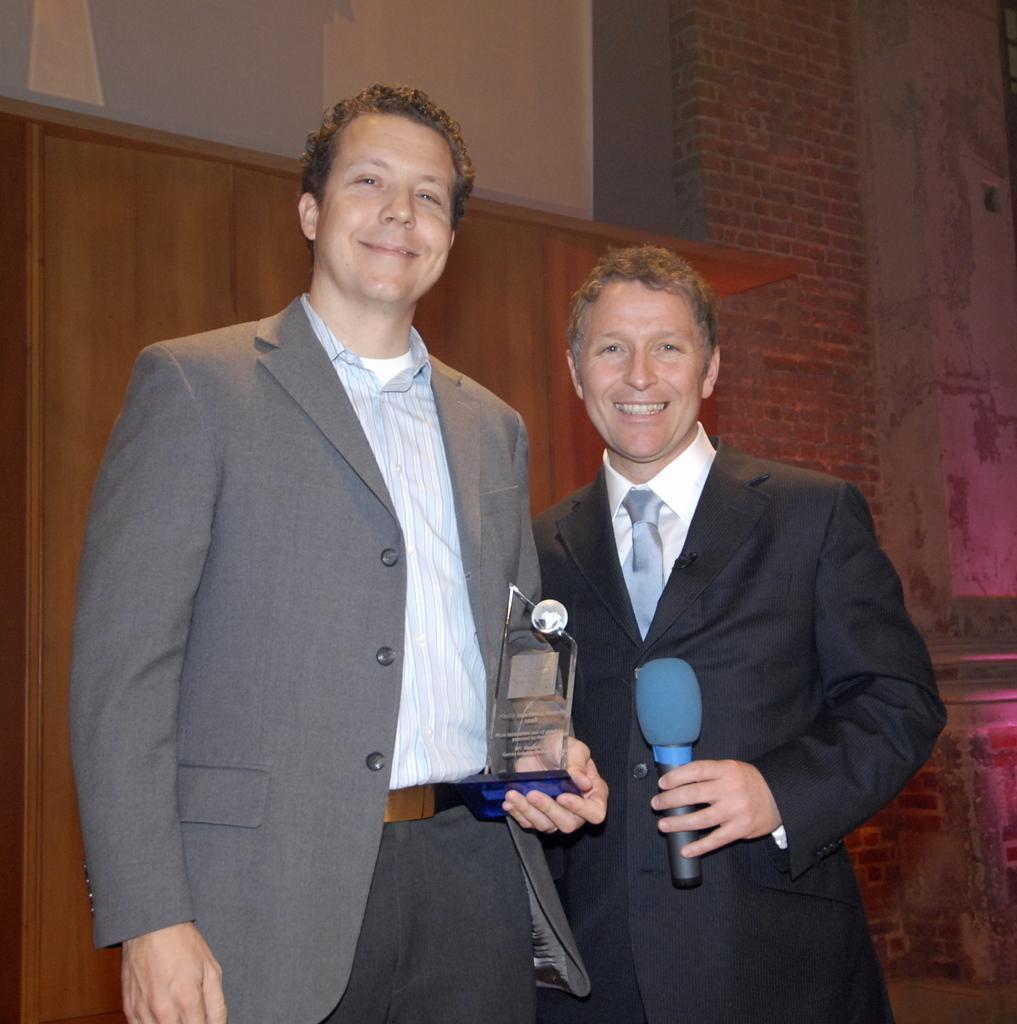Please provide a concise description of this image. In this picture I can see there are two men standing and they are wearing blazers, the man at the left side is holding an award, the man is on right side is holding a microphone. They are smiling and there is a wooden wall and there is a brick wall at the right side. 